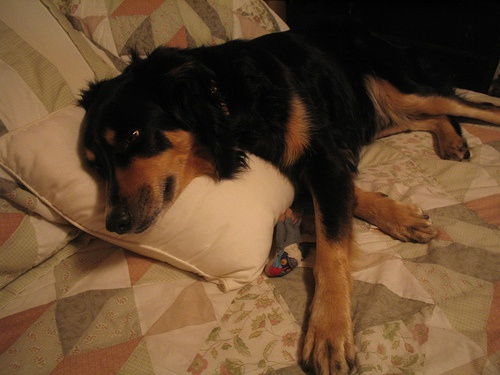Describe the objects in this image and their specific colors. I can see bed in gray, brown, and tan tones and dog in gray, black, maroon, and brown tones in this image. 